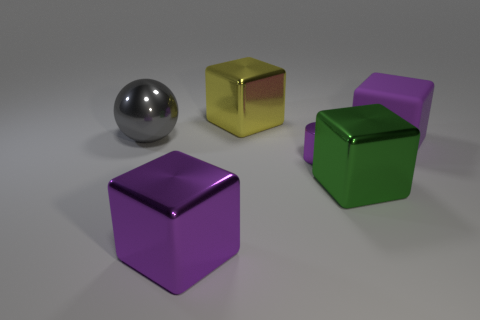What number of large objects are either purple blocks or red metallic spheres?
Your answer should be compact. 2. There is a matte thing; is its size the same as the green cube on the right side of the metal cylinder?
Your answer should be compact. Yes. Are there any other things that have the same shape as the small purple thing?
Make the answer very short. No. What number of yellow shiny cubes are there?
Your answer should be very brief. 1. What number of red objects are either cylinders or big rubber cubes?
Give a very brief answer. 0. Is the big object that is to the left of the big purple shiny thing made of the same material as the big yellow object?
Provide a short and direct response. Yes. What number of other objects are the same material as the green cube?
Your response must be concise. 4. What is the material of the tiny purple thing?
Offer a terse response. Metal. There is a purple block in front of the tiny thing; what is its size?
Your response must be concise. Large. There is a shiny object that is in front of the green object; what number of big spheres are to the left of it?
Offer a terse response. 1. 